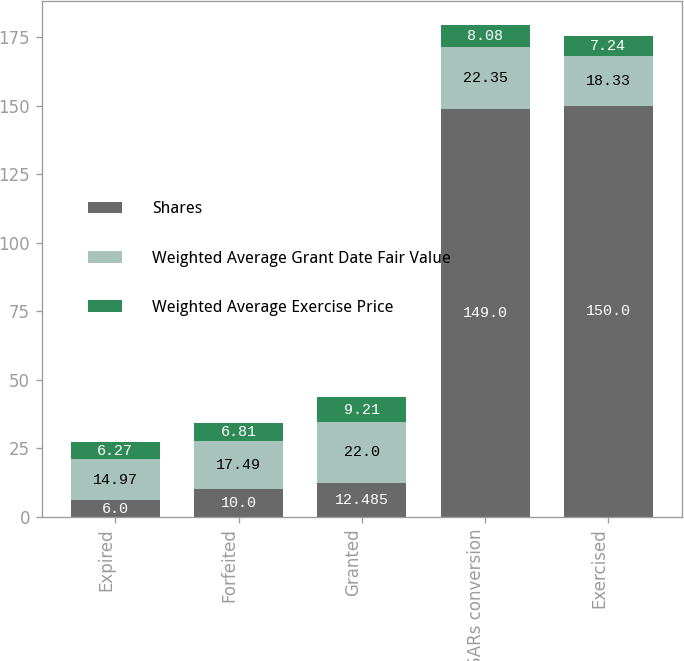<chart> <loc_0><loc_0><loc_500><loc_500><stacked_bar_chart><ecel><fcel>Expired<fcel>Forfeited<fcel>Granted<fcel>SARs conversion<fcel>Exercised<nl><fcel>Shares<fcel>6<fcel>10<fcel>12.485<fcel>149<fcel>150<nl><fcel>Weighted Average Grant Date Fair Value<fcel>14.97<fcel>17.49<fcel>22<fcel>22.35<fcel>18.33<nl><fcel>Weighted Average Exercise Price<fcel>6.27<fcel>6.81<fcel>9.21<fcel>8.08<fcel>7.24<nl></chart> 